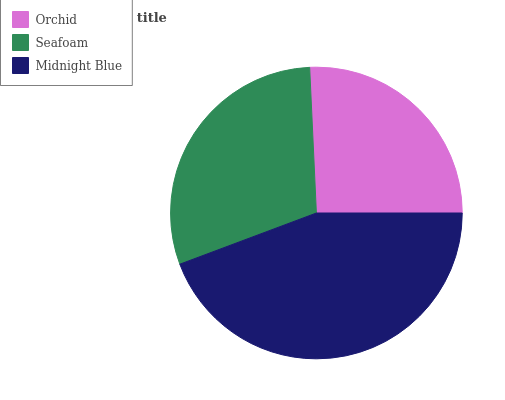Is Orchid the minimum?
Answer yes or no. Yes. Is Midnight Blue the maximum?
Answer yes or no. Yes. Is Seafoam the minimum?
Answer yes or no. No. Is Seafoam the maximum?
Answer yes or no. No. Is Seafoam greater than Orchid?
Answer yes or no. Yes. Is Orchid less than Seafoam?
Answer yes or no. Yes. Is Orchid greater than Seafoam?
Answer yes or no. No. Is Seafoam less than Orchid?
Answer yes or no. No. Is Seafoam the high median?
Answer yes or no. Yes. Is Seafoam the low median?
Answer yes or no. Yes. Is Midnight Blue the high median?
Answer yes or no. No. Is Orchid the low median?
Answer yes or no. No. 